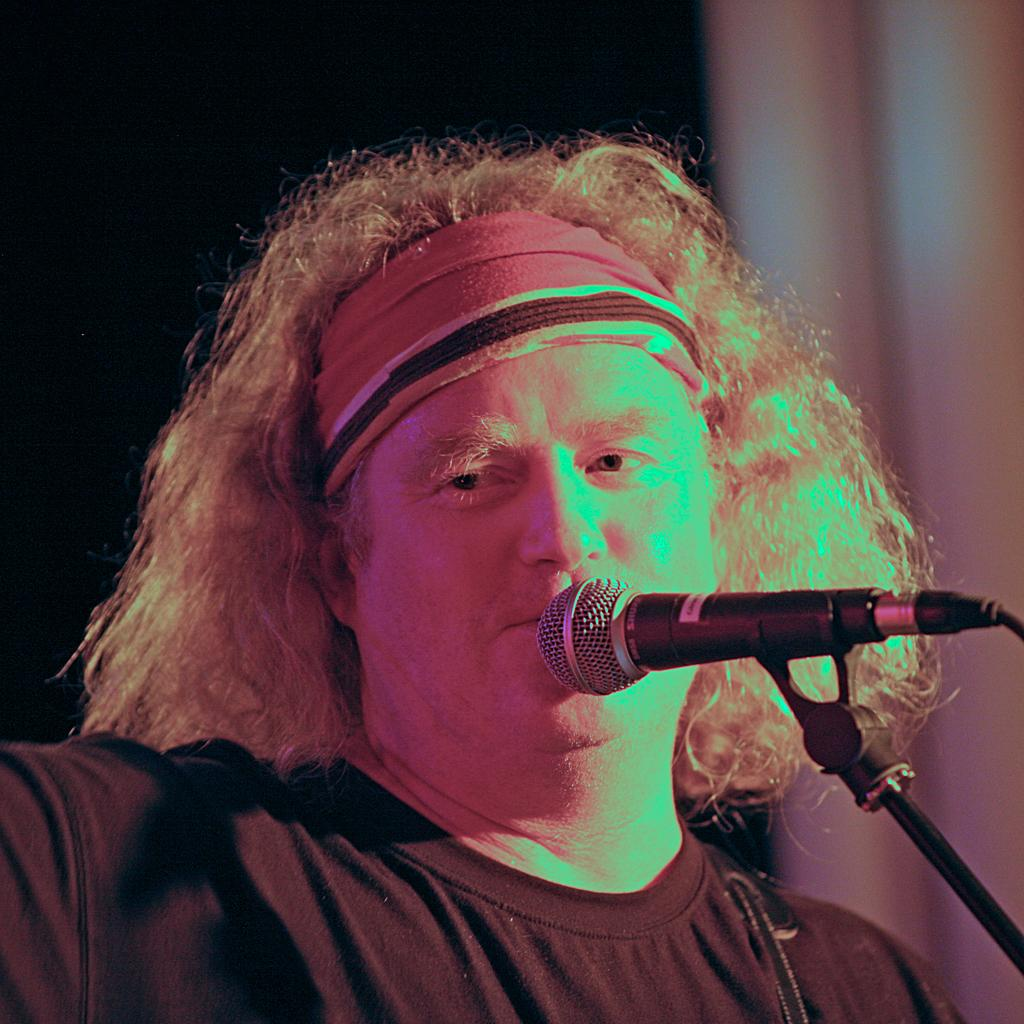What is the person in the image wearing? The person in the image is wearing a black dress. What object can be seen near the person in the image? There is a microphone (mic) in the image. What structure is visible in the image? There is a stand in the image. How is the image presented in terms of color? The background of the image is in black and white. What type of guide can be seen assisting the person in the image? There is no guide present in the image; it only features a person wearing a black dress, a microphone, a stand, and a black and white background. 